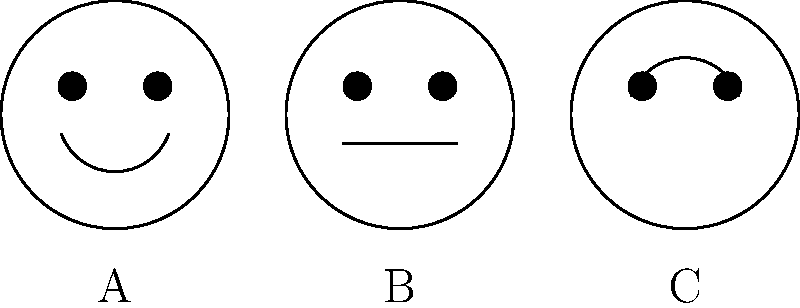Which cartoon face shows a happy emotion? To identify the happy emotion, we need to look at the key features of each face:

1. Face A:
   - The mouth is curved upwards in a "U" shape.
   - This is typically associated with a smile or happy expression.

2. Face B:
   - The mouth is a straight line.
   - This usually represents a neutral or serious expression.

3. Face C:
   - The mouth is curved downwards in an inverted "U" shape.
   - This commonly indicates a sad or upset expression.

In cartoon representations, a upward curved mouth (smile) is the most common and easily recognizable sign of happiness. Therefore, Face A shows the happy emotion.
Answer: A 